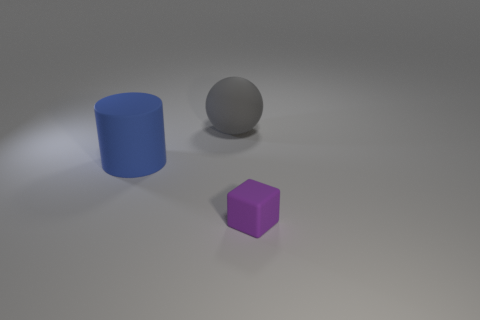Add 3 large green matte cylinders. How many objects exist? 6 Subtract all cylinders. How many objects are left? 2 Subtract all small yellow cylinders. Subtract all purple matte things. How many objects are left? 2 Add 1 large rubber objects. How many large rubber objects are left? 3 Add 1 big purple metal objects. How many big purple metal objects exist? 1 Subtract 0 green cubes. How many objects are left? 3 